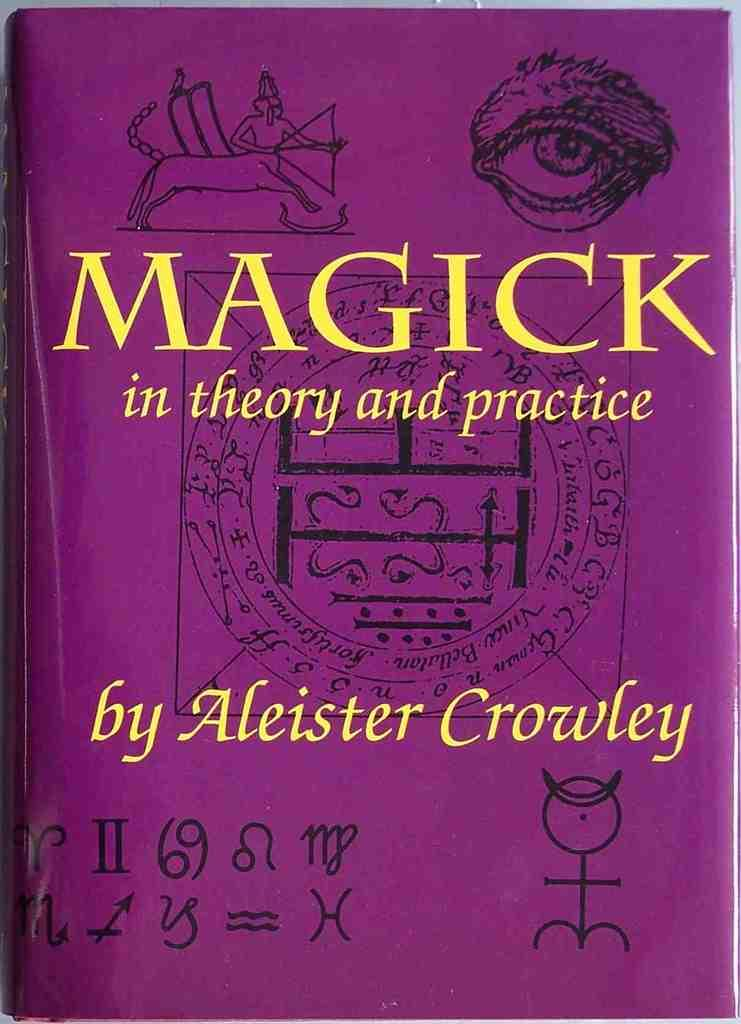<image>
Share a concise interpretation of the image provided. A purple cover with black symbols for a book by Aleister Crowley. 